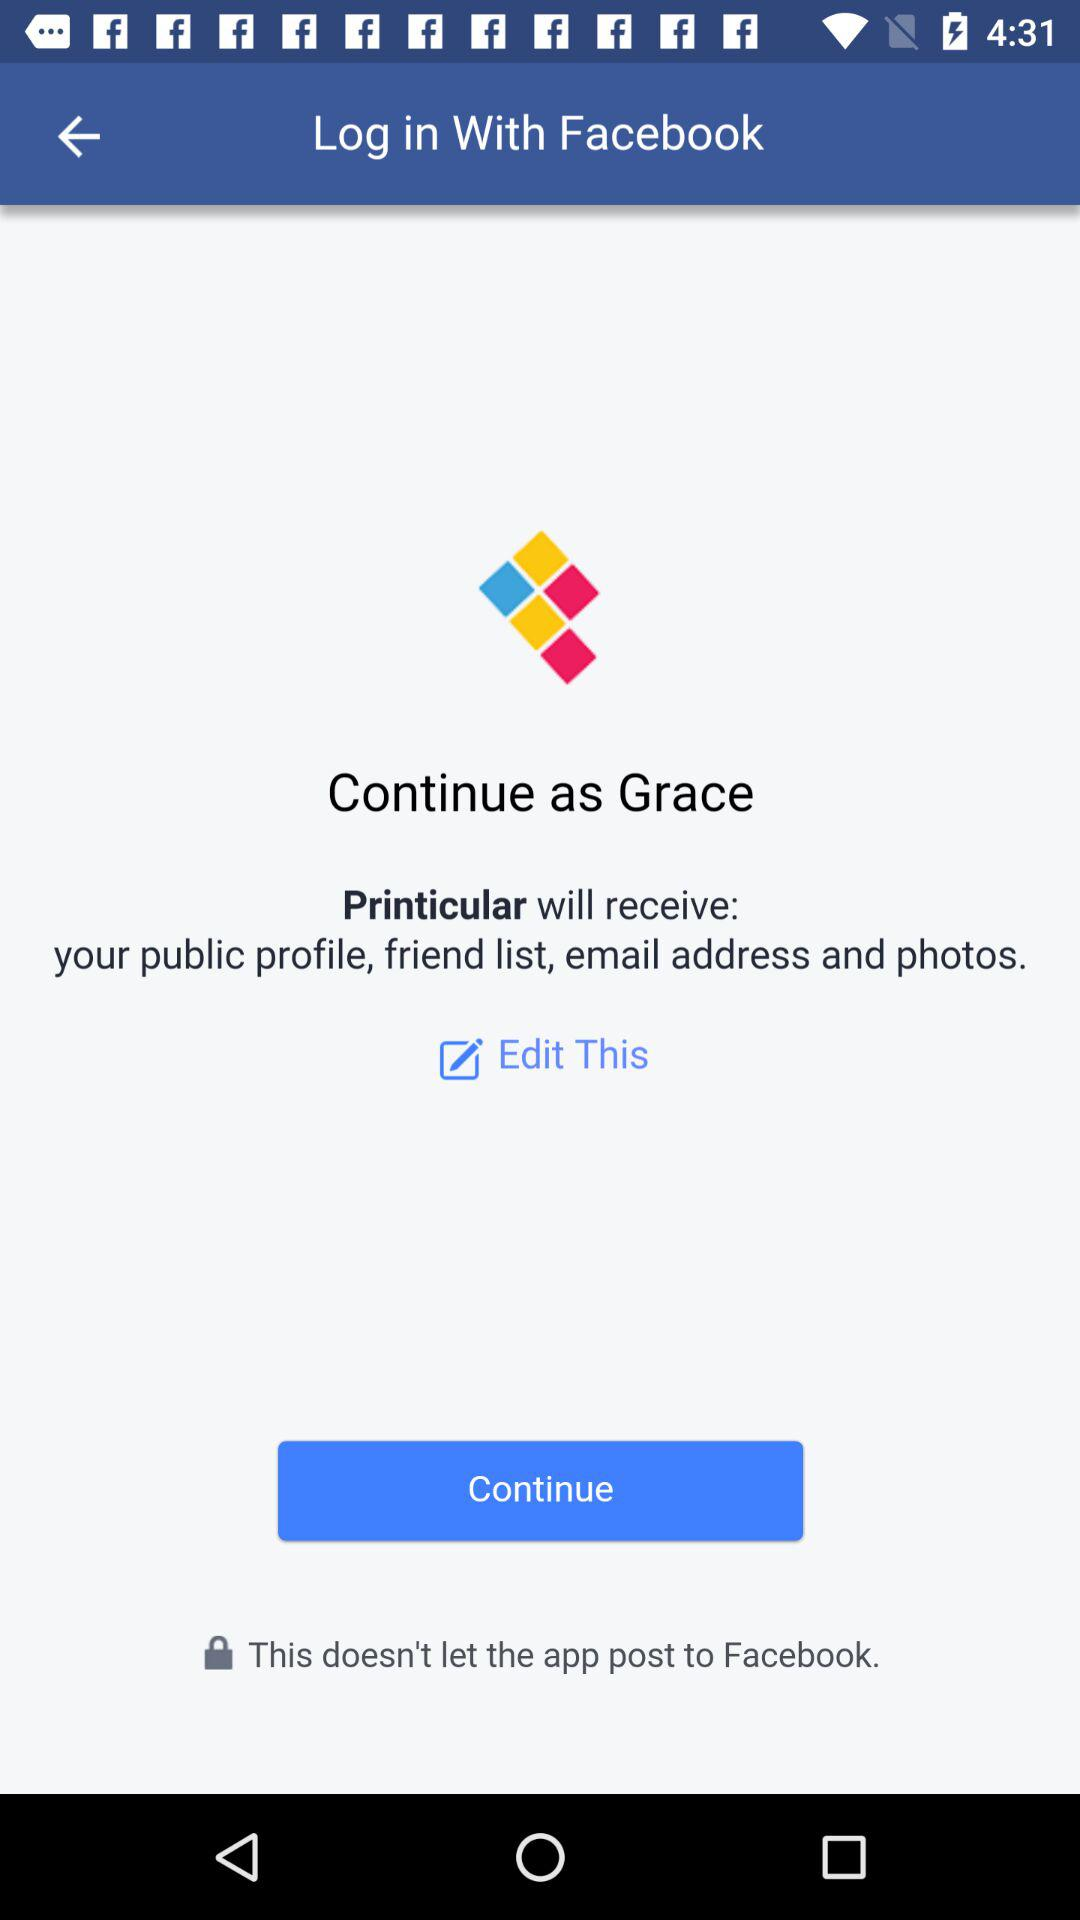What application will receive public profile, email address, and photos? The application is "Printicular". 